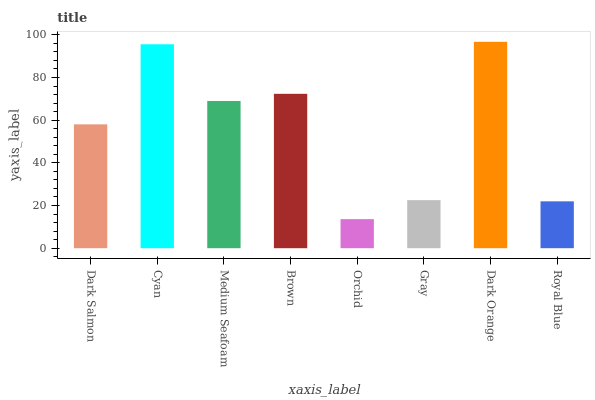Is Orchid the minimum?
Answer yes or no. Yes. Is Dark Orange the maximum?
Answer yes or no. Yes. Is Cyan the minimum?
Answer yes or no. No. Is Cyan the maximum?
Answer yes or no. No. Is Cyan greater than Dark Salmon?
Answer yes or no. Yes. Is Dark Salmon less than Cyan?
Answer yes or no. Yes. Is Dark Salmon greater than Cyan?
Answer yes or no. No. Is Cyan less than Dark Salmon?
Answer yes or no. No. Is Medium Seafoam the high median?
Answer yes or no. Yes. Is Dark Salmon the low median?
Answer yes or no. Yes. Is Dark Orange the high median?
Answer yes or no. No. Is Cyan the low median?
Answer yes or no. No. 